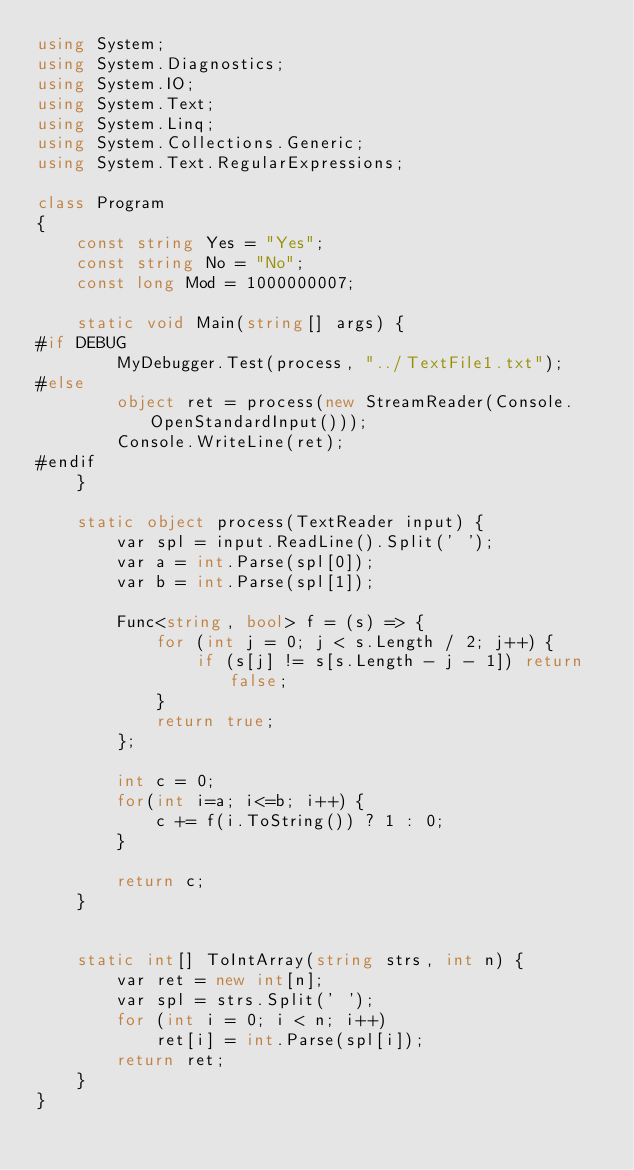<code> <loc_0><loc_0><loc_500><loc_500><_C#_>using System;
using System.Diagnostics;
using System.IO;
using System.Text;
using System.Linq;
using System.Collections.Generic;
using System.Text.RegularExpressions;

class Program
{
    const string Yes = "Yes";
    const string No = "No";
    const long Mod = 1000000007;

    static void Main(string[] args) {
#if DEBUG
        MyDebugger.Test(process, "../TextFile1.txt");
#else
        object ret = process(new StreamReader(Console.OpenStandardInput()));
        Console.WriteLine(ret);
#endif
    }

    static object process(TextReader input) {
        var spl = input.ReadLine().Split(' ');
        var a = int.Parse(spl[0]);
        var b = int.Parse(spl[1]);

        Func<string, bool> f = (s) => {
            for (int j = 0; j < s.Length / 2; j++) {
                if (s[j] != s[s.Length - j - 1]) return false;
            }
            return true;
        };

        int c = 0;
        for(int i=a; i<=b; i++) {
            c += f(i.ToString()) ? 1 : 0;
        }

        return c;
    }


    static int[] ToIntArray(string strs, int n) {
        var ret = new int[n];
        var spl = strs.Split(' ');
        for (int i = 0; i < n; i++)
            ret[i] = int.Parse(spl[i]);
        return ret;
    }
}
</code> 